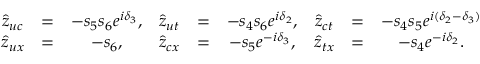Convert formula to latex. <formula><loc_0><loc_0><loc_500><loc_500>\begin{array} { c c c c c c c c c } { { \hat { z } _ { u c } } } & { = } & { { - s _ { 5 } s _ { 6 } e ^ { i \delta _ { 3 } } , } } & { { \hat { z } _ { u t } } } & { = } & { { - s _ { 4 } s _ { 6 } e ^ { i \delta _ { 2 } } , } } & { { \hat { z } _ { c t } } } & { = } & { { - s _ { 4 } s _ { 5 } e ^ { i ( \delta _ { 2 } - \delta _ { 3 } ) } } } \\ { { \hat { z } _ { u x } } } & { = } & { { - s _ { 6 } , } } & { { \hat { z } _ { c x } } } & { = } & { { - s _ { 5 } e ^ { - i \delta _ { 3 } } , } } & { { \hat { z } _ { t x } } } & { = } & { { - s _ { 4 } e ^ { - i \delta _ { 2 } } . } } \end{array}</formula> 